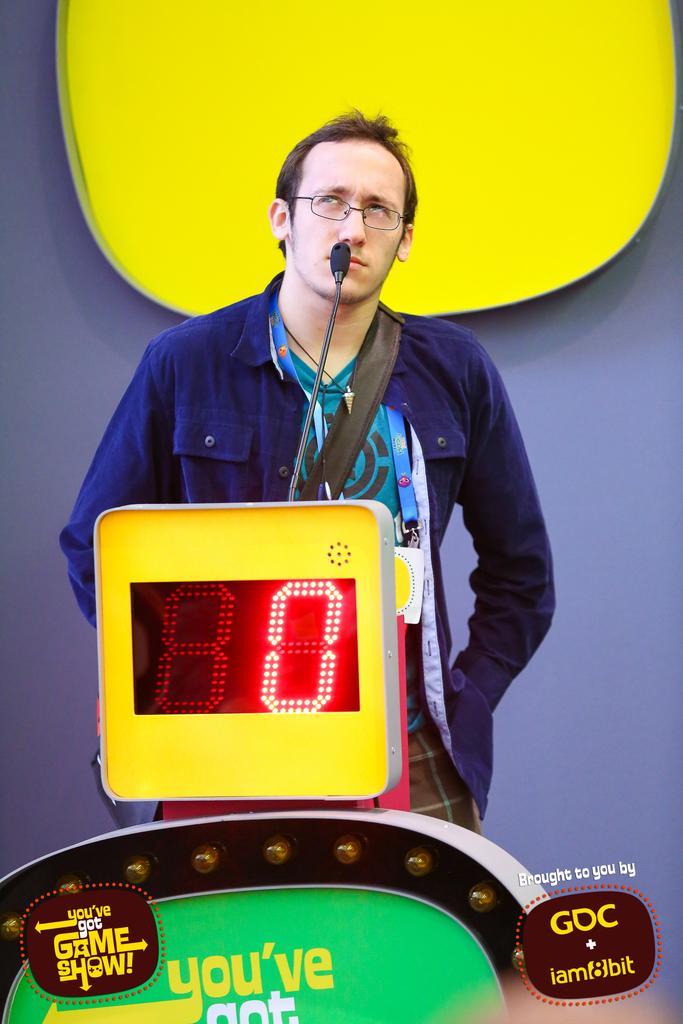How would you summarize this image in a sentence or two? In this image, we can see a person in front of the mic. This person is wearing clothes and spectacles. There is a screen in the middle of the image. There is an object and some text at the bottom of the image. 